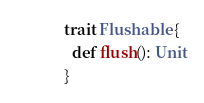Convert code to text. <code><loc_0><loc_0><loc_500><loc_500><_Scala_>trait Flushable {
  def flush(): Unit
}
</code> 